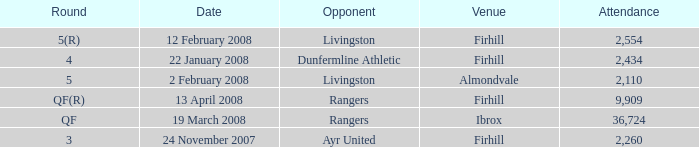Parse the table in full. {'header': ['Round', 'Date', 'Opponent', 'Venue', 'Attendance'], 'rows': [['5(R)', '12 February 2008', 'Livingston', 'Firhill', '2,554'], ['4', '22 January 2008', 'Dunfermline Athletic', 'Firhill', '2,434'], ['5', '2 February 2008', 'Livingston', 'Almondvale', '2,110'], ['QF(R)', '13 April 2008', 'Rangers', 'Firhill', '9,909'], ['QF', '19 March 2008', 'Rangers', 'Ibrox', '36,724'], ['3', '24 November 2007', 'Ayr United', 'Firhill', '2,260']]} What is the average attendance at a game held at Firhill for the 5(r) round? 2554.0. 